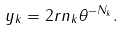Convert formula to latex. <formula><loc_0><loc_0><loc_500><loc_500>y _ { k } = 2 r n _ { k } \theta ^ { - N _ { k } } .</formula> 